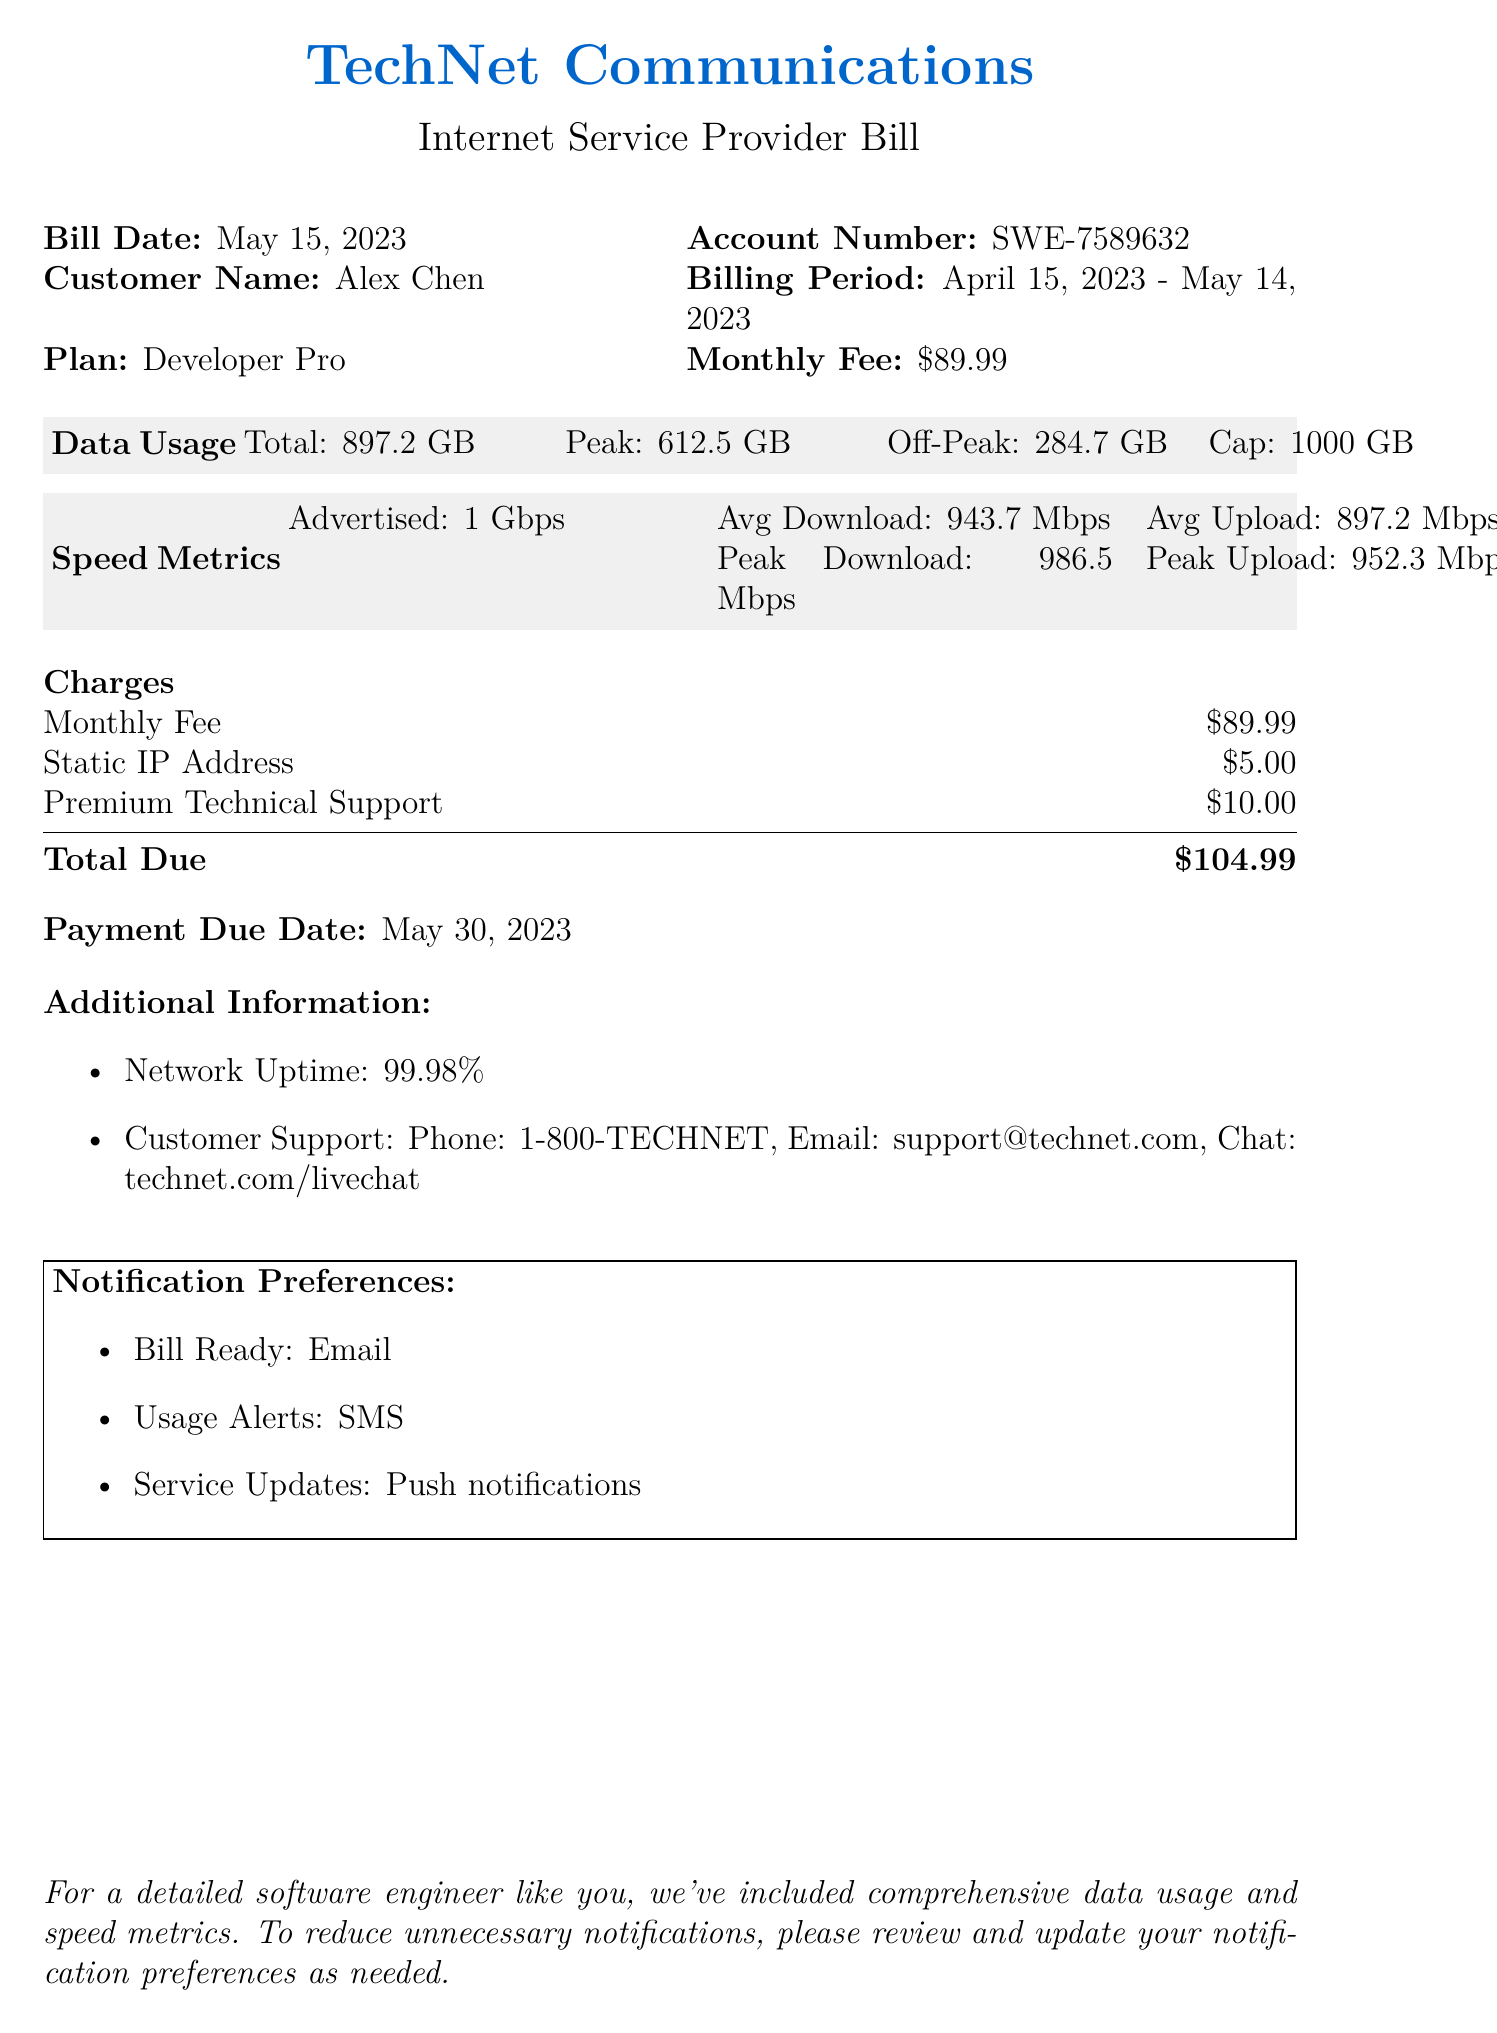What is the bill date? The bill date is specified in the document under the billing information section.
Answer: May 15, 2023 What is the account number? The account number is provided alongside other customer details in the document.
Answer: SWE-7589632 What is the total data usage? Total data usage is mentioned under the data usage section.
Answer: 897.2 GB What is the average download speed? The average download speed is found in the speed metrics section of the bill.
Answer: 943.7 Mbps What is the total amount due? The total amount due is summarized in the charges section at the end of the document.
Answer: $104.99 What is the payment due date? The payment due date is explicitly stated in the summary section.
Answer: May 30, 2023 What additional service is charged $10.00? This service fee is outlined in the charges section.
Answer: Premium Technical Support What is the plan type? The plan type is specified under the customer details section of the document.
Answer: Developer Pro What is the network uptime percentage? This information is provided in the additional information section of the bill.
Answer: 99.98% 